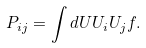<formula> <loc_0><loc_0><loc_500><loc_500>P _ { i j } = \int d { U } U _ { i } U _ { j } f .</formula> 